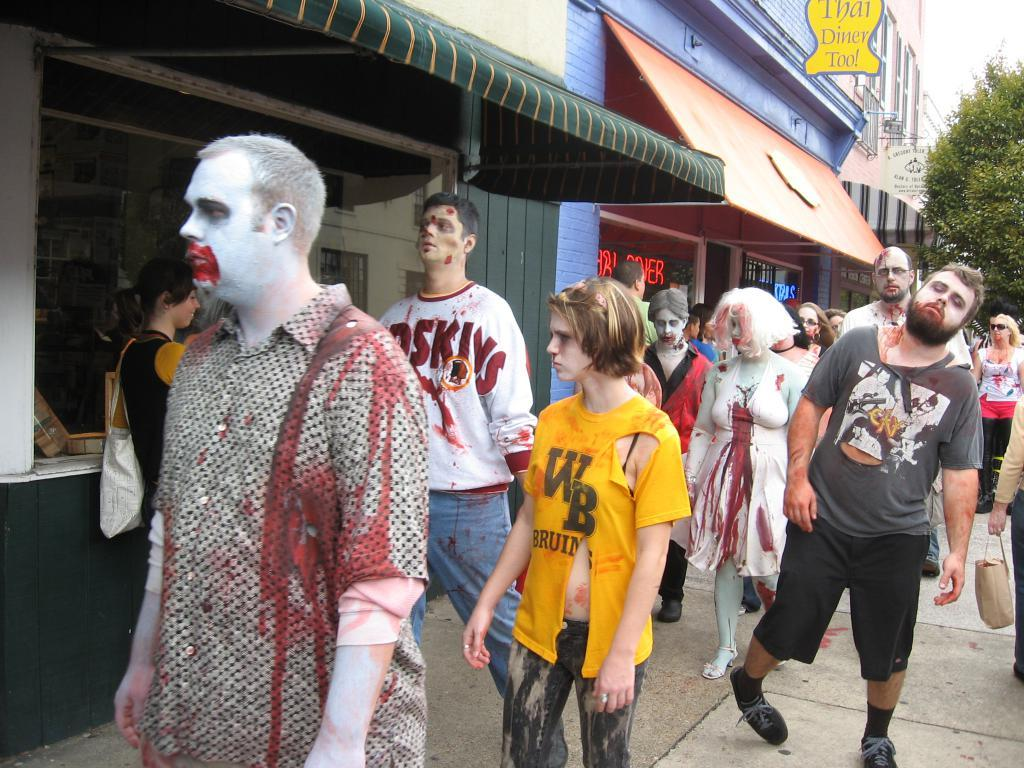What are the people in the image wearing? The people in the image are wearing Halloween costumes. Where are the people located in the image? The people are on the road in the image. What can be seen in the background of the image? There are buildings and a tree in the image. What is attached to the buildings in the image? There is a board attached to the buildings in the image. What type of wax can be seen melting on the street in the image? There is no wax present in the image, and therefore no wax can be seen melting on the street. 